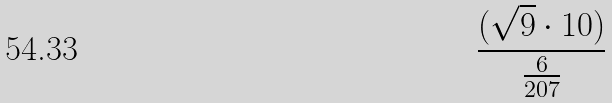Convert formula to latex. <formula><loc_0><loc_0><loc_500><loc_500>\frac { ( \sqrt { 9 } \cdot 1 0 ) } { \frac { 6 } { 2 0 7 } }</formula> 